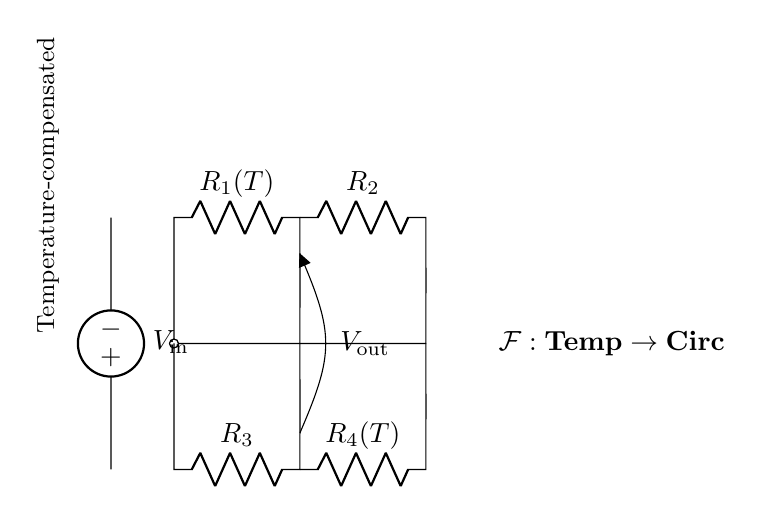What is the output voltage in this circuit? The output voltage is denoted as V out, which is specifically indicated in the circuit diagram as the voltage across the junction of the resistors R 2 and R 4.
Answer: V out What are the values of the resistors R 1 and R 4 based on temperature? The values of R 1 and R 4 vary with temperature, as indicated by R 1(T) and R 4(T), which suggest that these resistors are temperature-dependent.
Answer: R 1(T), R 4(T) How many resistors are present in this circuit? There are four resistors in total: R 1, R 2, R 3, and R 4, as shown in the diagram.
Answer: Four What is the role of the voltage source in this bridge circuit? The voltage source V in provides the necessary input to the bridge circuit, influencing the potential difference across the resistors and determining the output voltage.
Answer: Provide input Explain the relationship between R 2 and R 3 in balancing the bridge. R 2 and R 3 are part of the bridge configuration, where their values can be adjusted to achieve balance, which minimizes the output voltage V out. A balanced bridge occurs when the ratio of their resistances matches the ratios of R 1 and R 4.
Answer: Balance the bridge What type of circuit is represented by the diagram? The circuit displayed is a temperature-compensated bridge circuit, indicated by the annotations and the structure that aims to maintain balance despite temperature changes affecting R 1 and R 4.
Answer: Temperature-compensated bridge How does temperature affect the performance of this circuit? Temperature alters the resistance values of R 1 and R 4 due to their respective temperature dependencies, which can affect the balance of the bridge and consequently the output voltage V out. The compensation is aimed at counteracting these variations.
Answer: Affects balance/output 